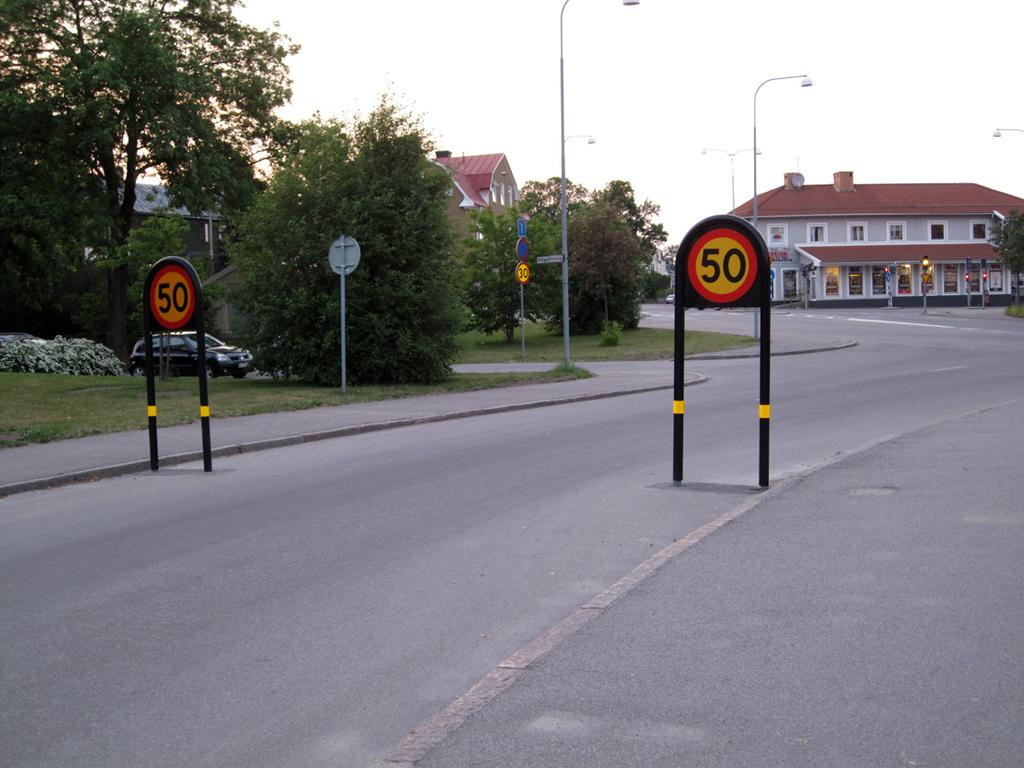<image>
Create a compact narrative representing the image presented. Sign outside that says the number 50 on it. 